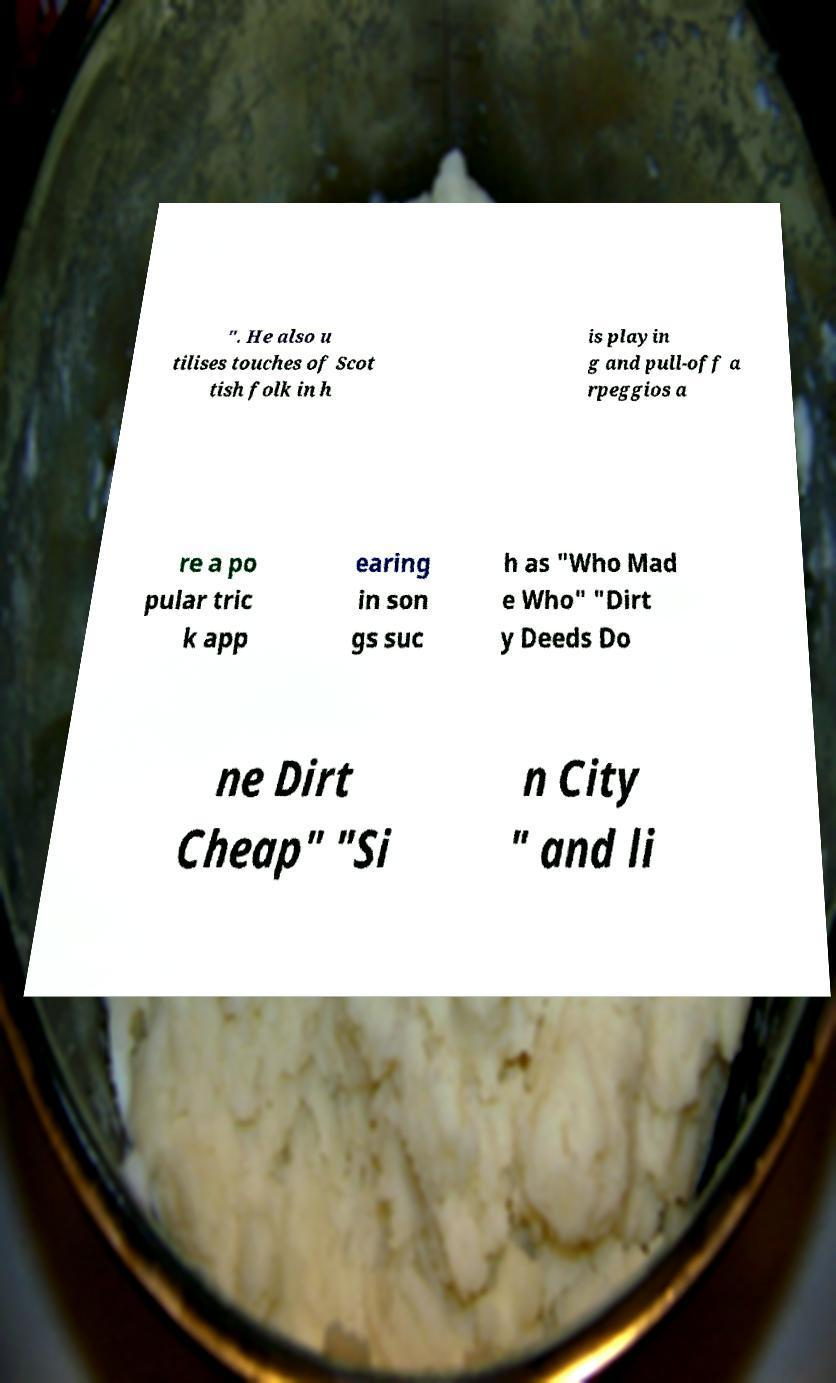Please identify and transcribe the text found in this image. ". He also u tilises touches of Scot tish folk in h is playin g and pull-off a rpeggios a re a po pular tric k app earing in son gs suc h as "Who Mad e Who" "Dirt y Deeds Do ne Dirt Cheap" "Si n City " and li 